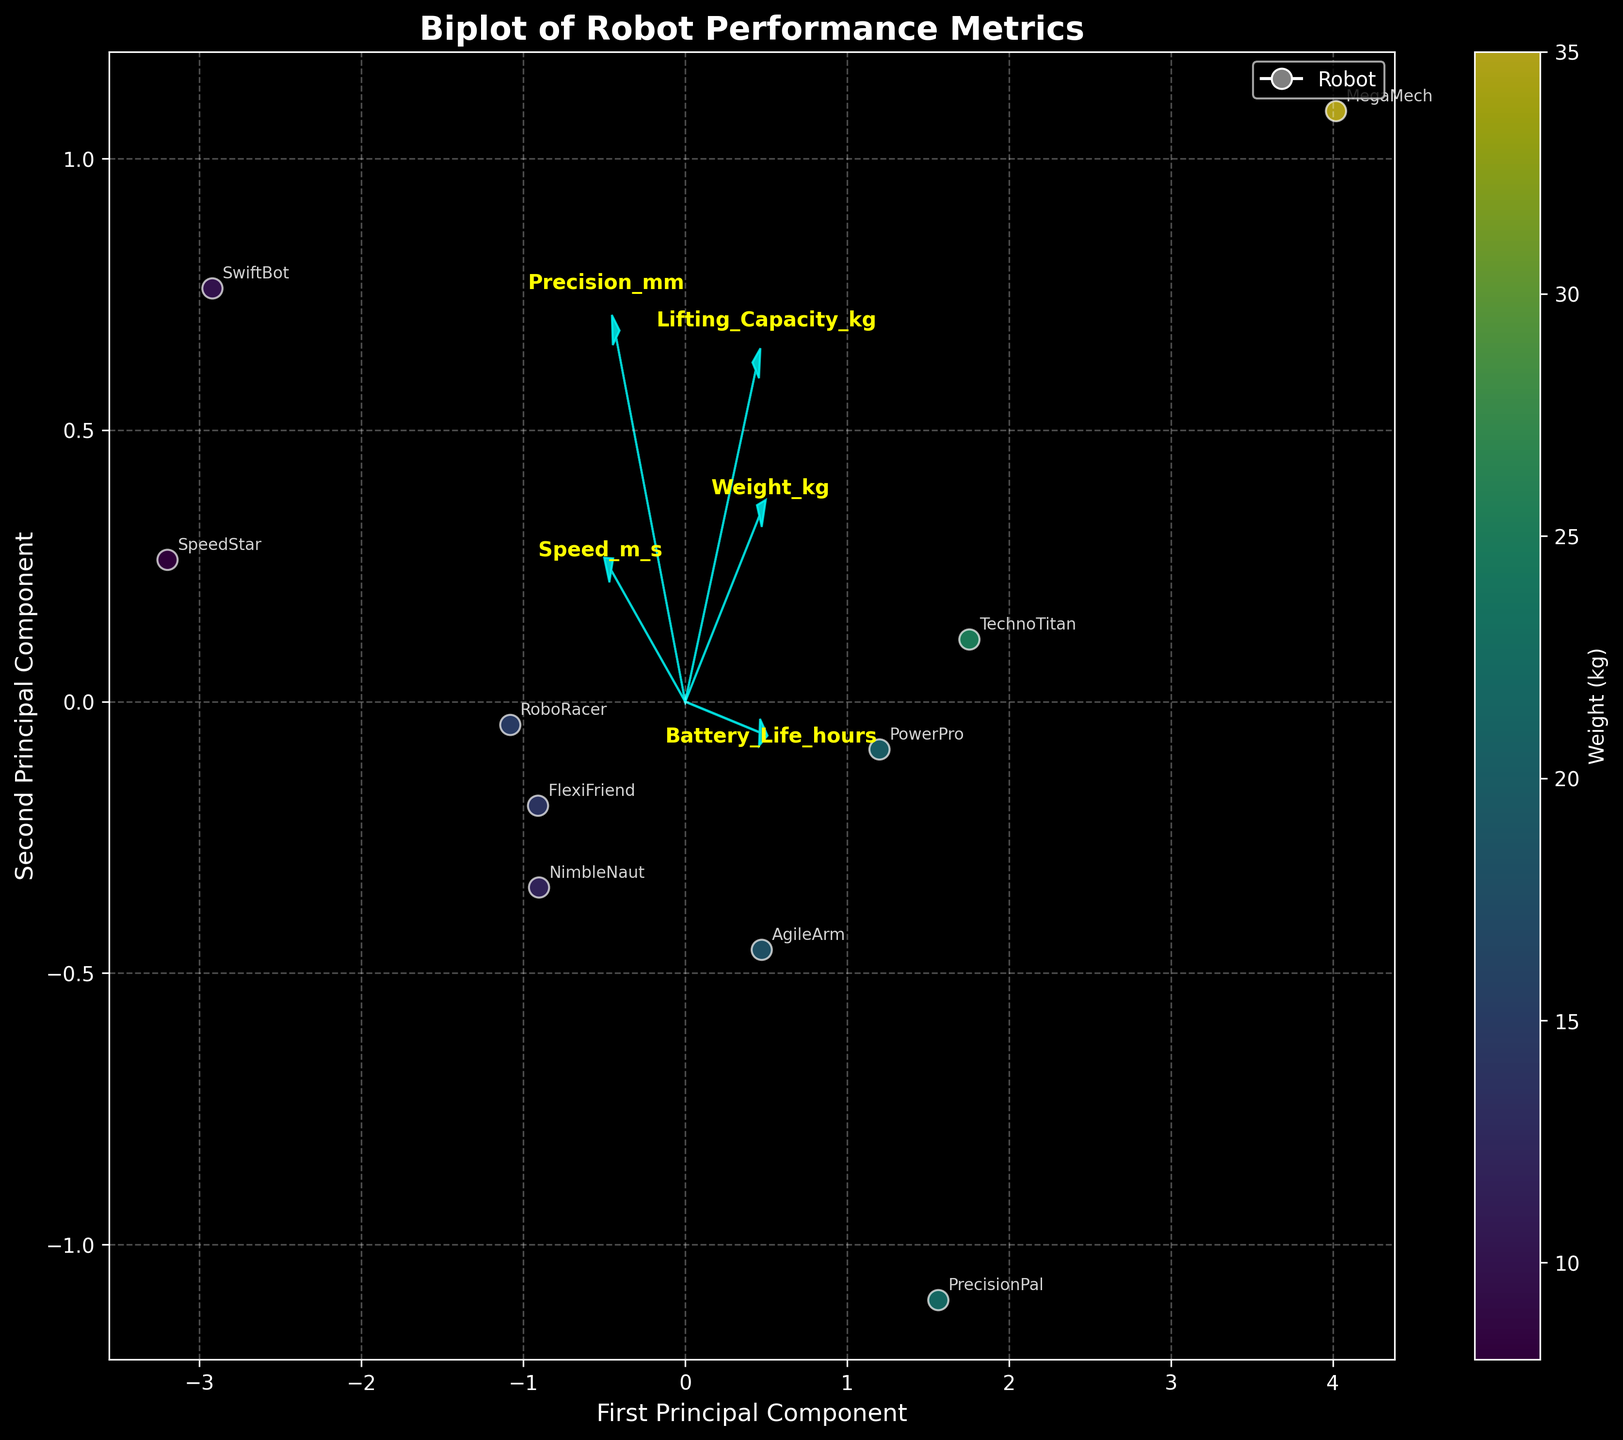How many robots are represented in the biplot? To find the number of robots shown, we count the number of unique labels (robot names) on the plot.
Answer: 10 Which feature vector is longest, indicating the most variance explained by the principal components? The longest feature vector on the biplot represents the feature with the greatest variance explained by the principal components.
Answer: Weight_kg Which robot appears to have the highest value on the first principal component? To determine this, we locate the robot whose position on the biplot is farthest to the right along the x-axis.
Answer: SpeedStar Which robot has a combination of high speed and moderate battery life? We need to look for a robot positioned towards the positive direction of the 'Speed_m_s' vector and moderately near the 'Battery_Life_hours' vector.
Answer: NimbleNaut How do SpeedStar and TechnoTitan compare in terms of precision? We observe the positions of these two robots concerning the 'Precision_mm' vector to compare their precision directly.
Answer: SpeedStar has higher precision Which two features are almost orthogonal, indicating little correlation between them? Orthogonal vectors on the biplot represent features with little to no correlation. We look for vectors that form a roughly 90-degree angle.
Answer: Speed_m_s and Weight_kg What does the color of the scatter points represent in the biplot? The color of the scatter points indicates a specific feature, as described in the color bar.
Answer: Weight_kg Which feature contributes the least to the first two principal components? On the biplot, the feature vector with the smallest magnitude indicates the least contribution to the first two principal components.
Answer: Precision_mm Can you identify a robot that is light in weight yet has high speed? We look for a scatter point that is both brightly colored (indicating low weight) and positioned far from the origin in the direction of the 'Speed_m_s' vector.
Answer: SwiftBot Is there a robot with high lifting capacity and battery life? We find the robot positioned furthest in the positive direction of both the 'Lifting_Capacity_kg' and 'Battery_Life_hours' vectors.
Answer: MegaMech 